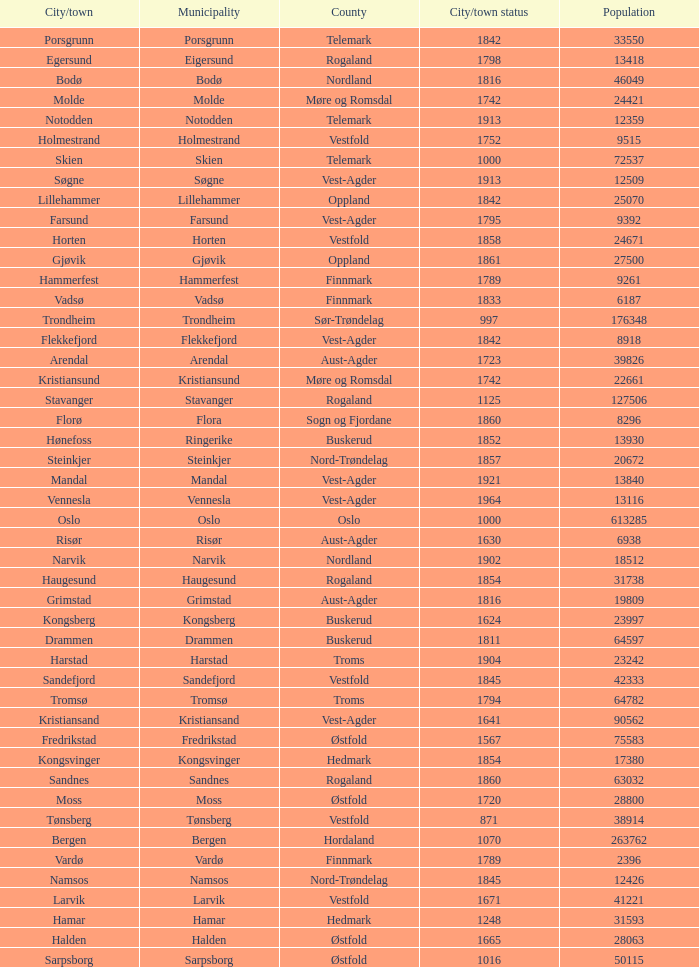Which municipalities located in the county of Finnmark have populations bigger than 6187.0? Hammerfest. 